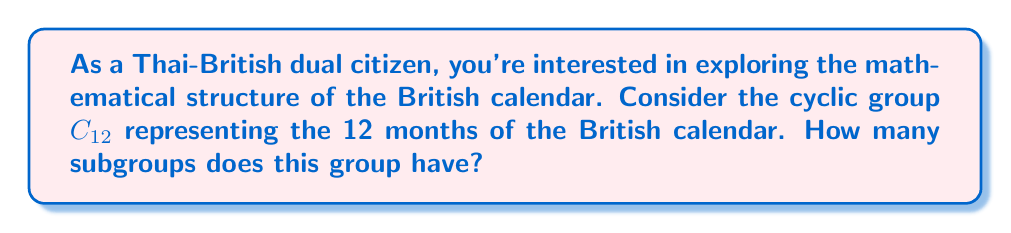Can you solve this math problem? Let's approach this step-by-step:

1) First, recall that the number of subgroups in a cyclic group $C_n$ is equal to the number of divisors of $n$.

2) In this case, we're dealing with $C_{12}$, so we need to find the divisors of 12.

3) The divisors of 12 are: 1, 2, 3, 4, 6, and 12.

4) Each of these divisors corresponds to a subgroup:
   - $\langle e \rangle$ (identity subgroup, order 1)
   - $\langle 6 \rangle$ (subgroup of order 2)
   - $\langle 4 \rangle$ (subgroup of order 3)
   - $\langle 3 \rangle$ (subgroup of order 4)
   - $\langle 2 \rangle$ (subgroup of order 6)
   - $\langle 1 \rangle$ (the entire group, order 12)

5) To visualize this, we can think of the months as a clock face:
   [asy]
   import geometry;
   
   size(100);
   real r = 4;
   for(int i=0; i<12; ++i) {
     dot((r*cos(2pi*i/12), r*sin(2pi*i/12)));
   }
   draw(circle((0,0), r));
   [/asy]

   Each subgroup corresponds to a way of "jumping" around this clock face.

6) In the context of the British calendar:
   - The subgroup of order 1 is just January.
   - The subgroup of order 2 alternates between January and July.
   - The subgroup of order 3 cycles through January, May, September.
   - The subgroup of order 4 cycles through January, April, July, October.
   - The subgroup of order 6 cycles through January, March, May, July, September, November.
   - The subgroup of order 12 is the entire calendar.

Therefore, the cyclic group $C_{12}$ representing the 12 months of the British calendar has 6 subgroups.
Answer: 6 subgroups 